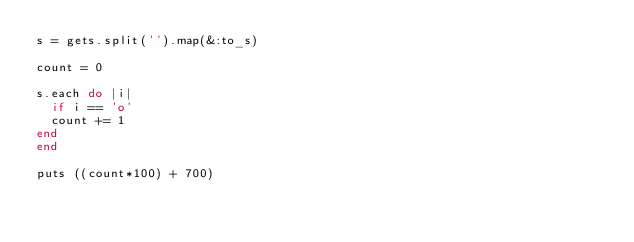<code> <loc_0><loc_0><loc_500><loc_500><_Ruby_>s = gets.split('').map(&:to_s)

count = 0

s.each do |i|
	if i == 'o'
	count += 1
end
end

puts ((count*100) + 700)</code> 